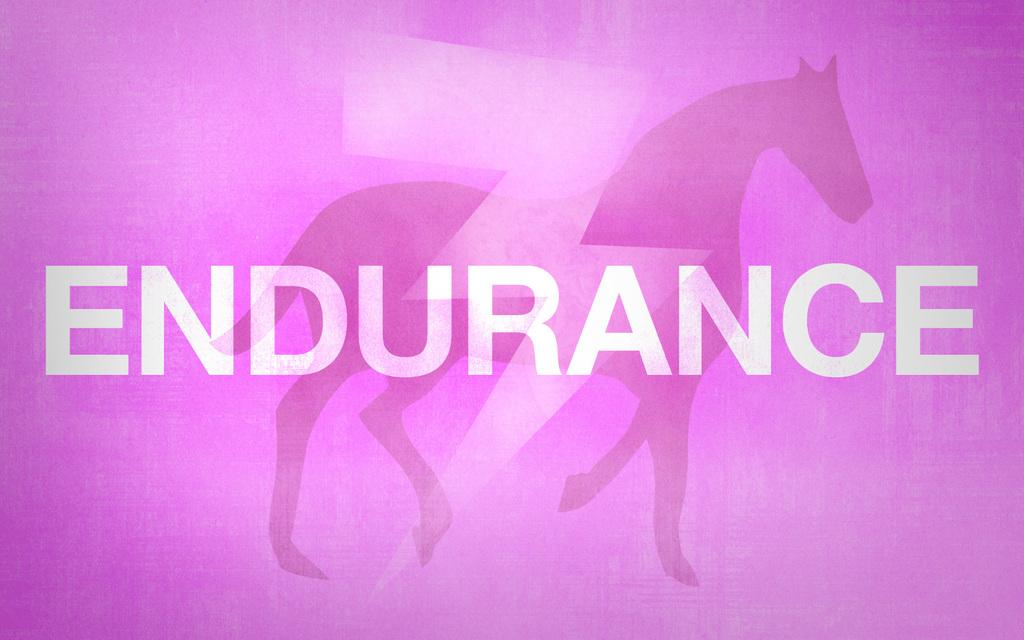What is the main subject of the image? The main subject of the image is a horse. Can you describe any additional elements in the image? Yes, there is text visible on the screen. How does the system affect the horse's ability to brake in the image? There is no system or reference to braking in the image; it features an image of a horse and text on a screen. 